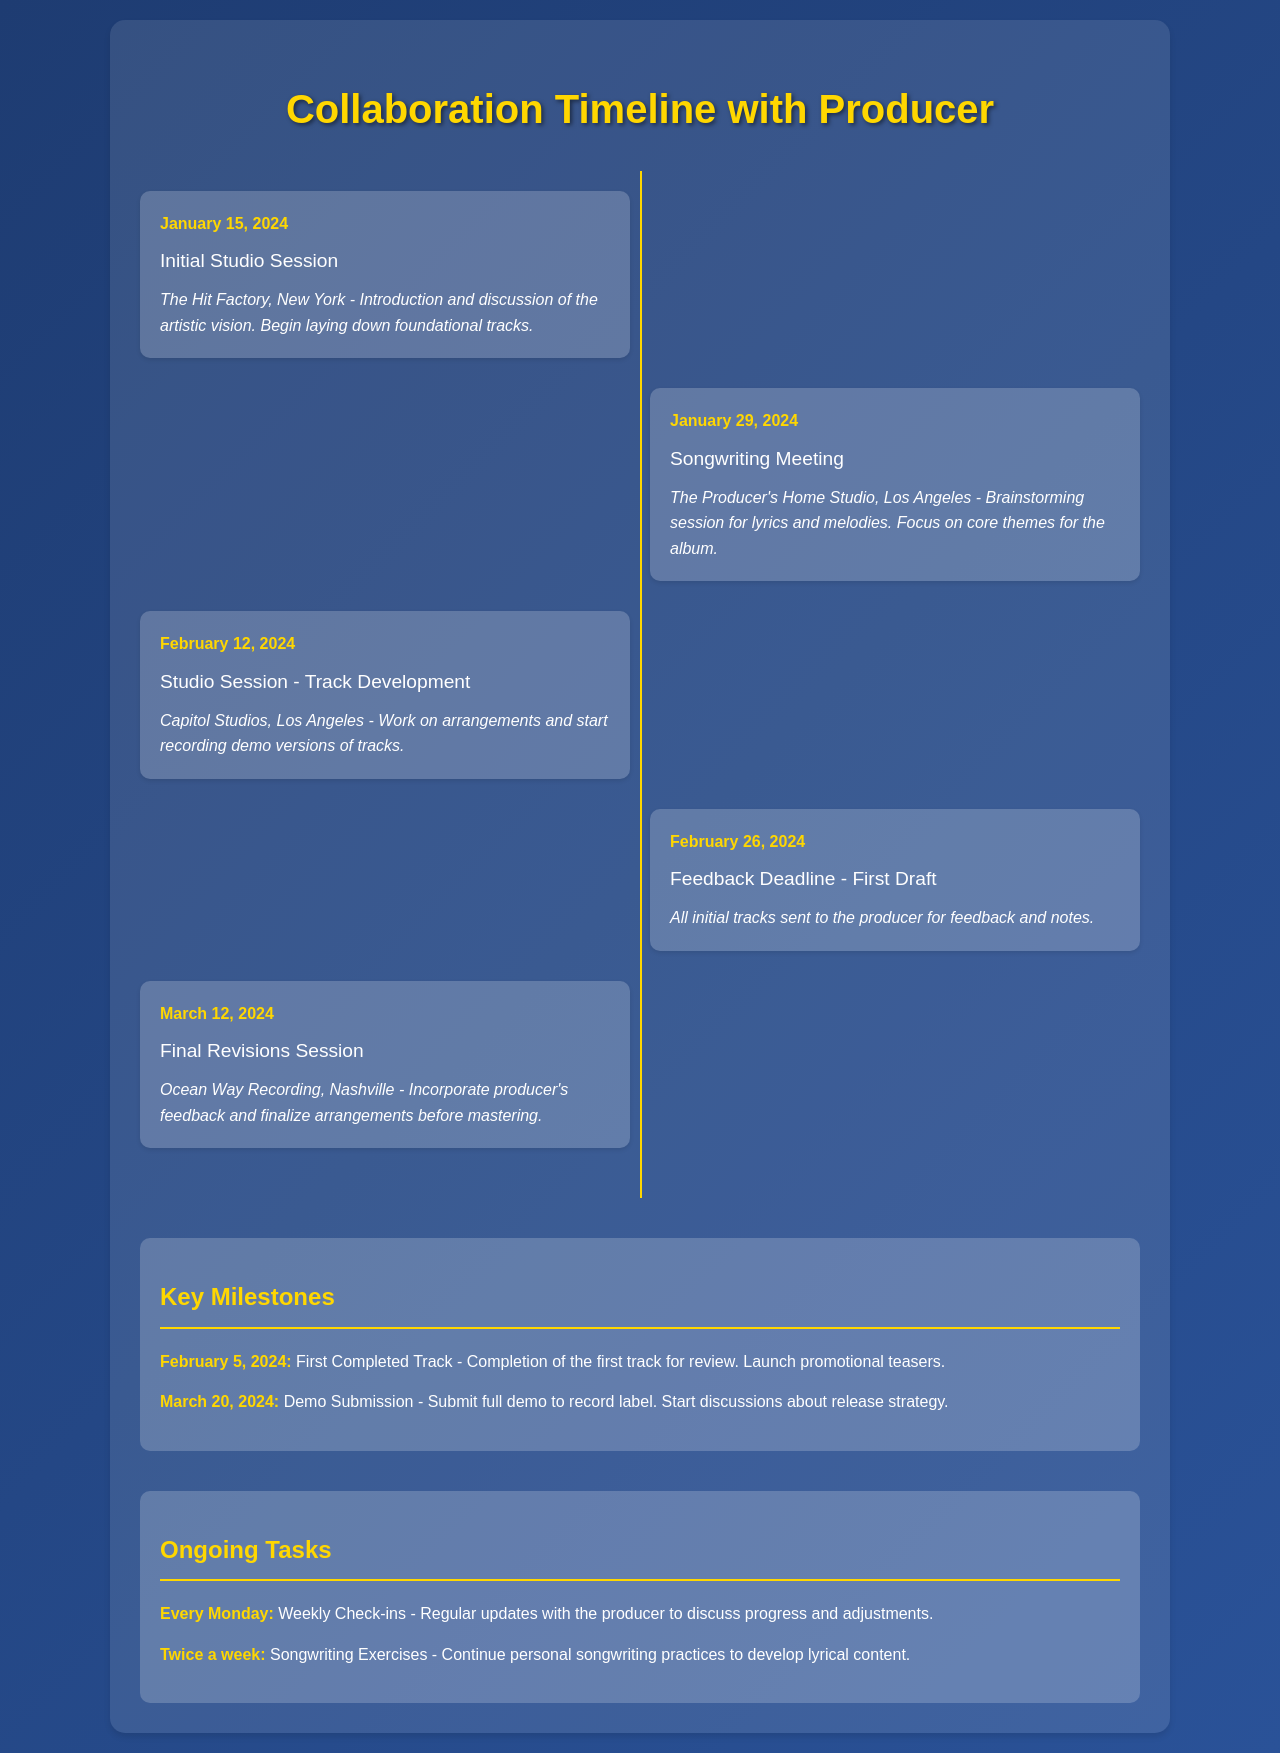what is the date of the initial studio session? The initial studio session is listed on January 15, 2024.
Answer: January 15, 2024 where will the first songwriting meeting take place? The first songwriting meeting will take place at The Producer's Home Studio in Los Angeles.
Answer: The Producer's Home Studio, Los Angeles what is the milestone date for the first completed track? The milestone date for the first completed track is February 5, 2024.
Answer: February 5, 2024 how many studio sessions are scheduled before the feedback deadline? There are two studio sessions scheduled before the feedback deadline.
Answer: Two what is the purpose of the feedback deadline on February 26, 2024? The purpose of the feedback deadline is to send all initial tracks to the producer for feedback and notes.
Answer: Feedback and notes what type of exercises are scheduled to occur twice a week? The exercises scheduled to occur twice a week are songwriting exercises.
Answer: Songwriting exercises when will the final revisions session occur? The final revisions session will occur on March 12, 2024.
Answer: March 12, 2024 which recording location is mentioned for the studio session on February 12, 2024? The recording location mentioned for the studio session on February 12, 2024, is Capitol Studios, Los Angeles.
Answer: Capitol Studios, Los Angeles who is involved in the ongoing weekly check-ins? The producer is involved in the ongoing weekly check-ins.
Answer: The producer 